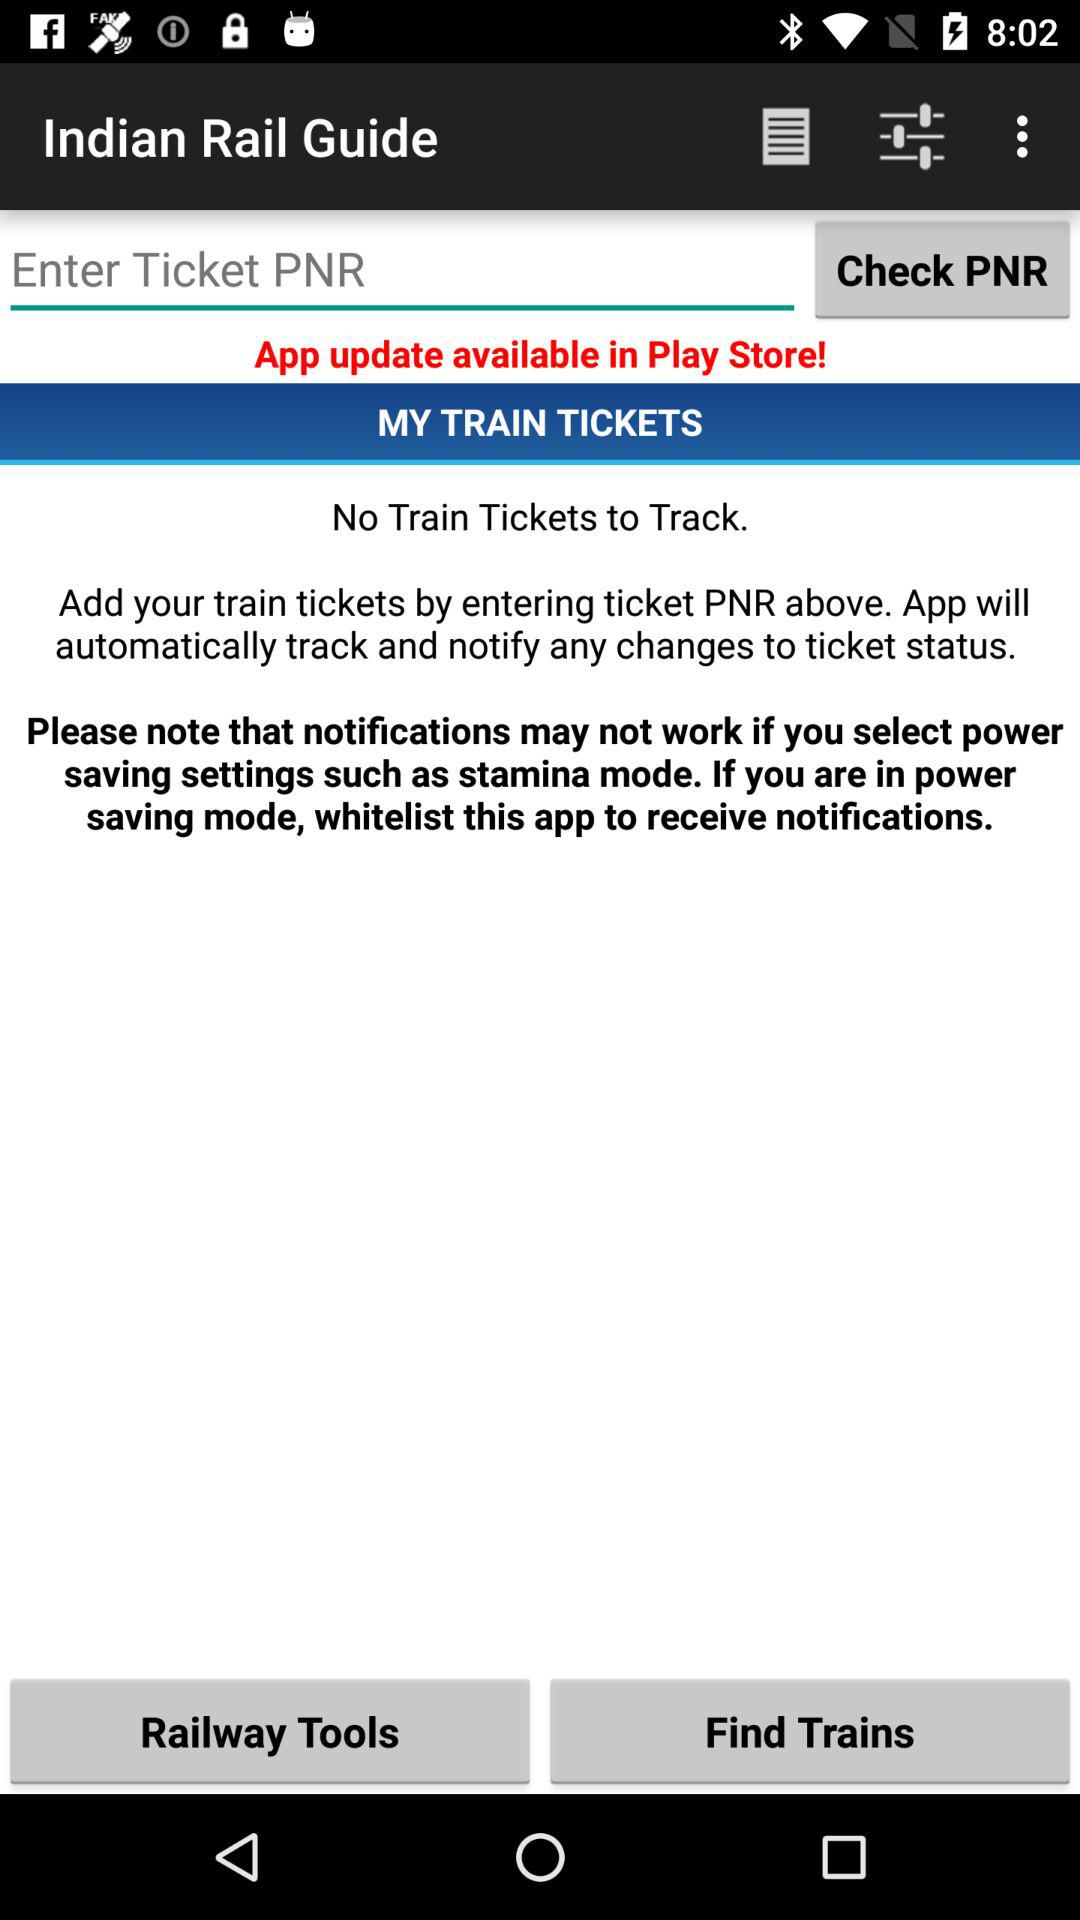How many train tickets are there to track? There are no train tickets to track. 